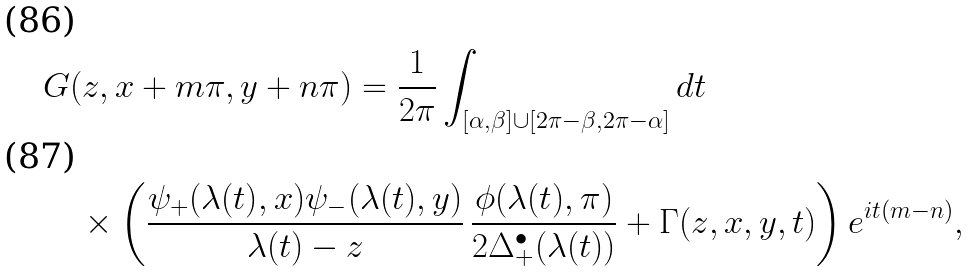Convert formula to latex. <formula><loc_0><loc_0><loc_500><loc_500>& G ( z , x + m \pi , y + n \pi ) = \frac { 1 } { 2 \pi } \int _ { [ \alpha , \beta ] \cup [ 2 \pi - \beta , 2 \pi - \alpha ] } d t \\ & \quad \times \left ( \frac { \psi _ { + } ( \lambda ( t ) , x ) \psi _ { - } ( \lambda ( t ) , y ) } { \lambda ( t ) - z } \, \frac { \phi ( \lambda ( t ) , \pi ) } { 2 \Delta _ { + } ^ { \bullet } ( \lambda ( t ) ) } + \Gamma ( z , x , y , t ) \right ) e ^ { i t ( m - n ) } ,</formula> 